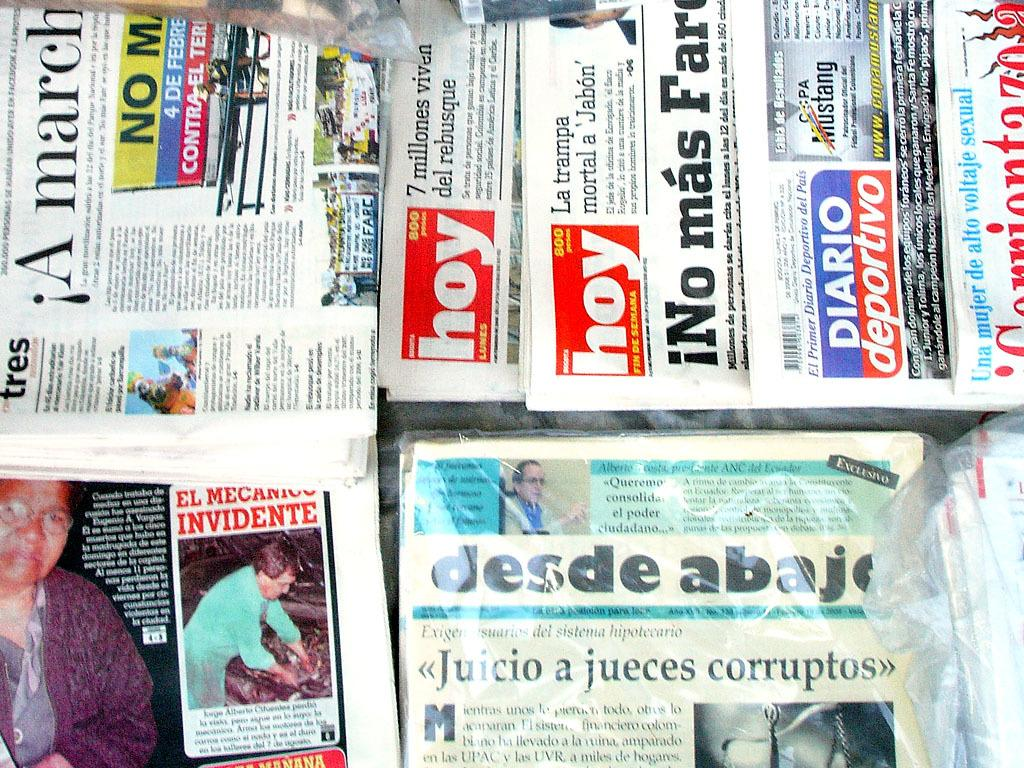<image>
Create a compact narrative representing the image presented. newspaper stand one called desde abajo and hoy 